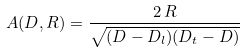<formula> <loc_0><loc_0><loc_500><loc_500>A ( D , R ) = \frac { 2 \, R } { \sqrt { ( D - D _ { l } ) ( D _ { t } - D ) } }</formula> 